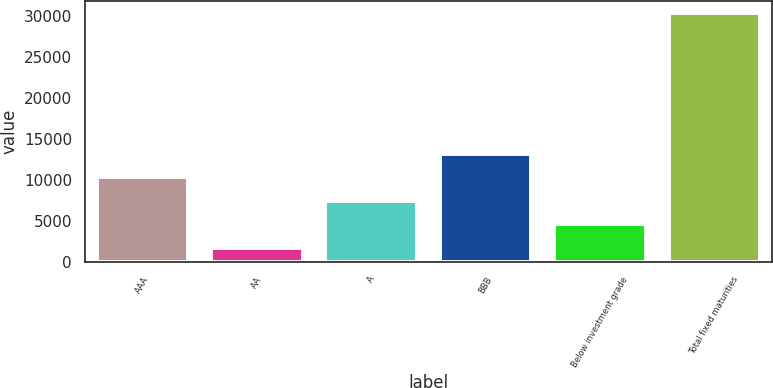Convert chart to OTSL. <chart><loc_0><loc_0><loc_500><loc_500><bar_chart><fcel>AAA<fcel>AA<fcel>A<fcel>BBB<fcel>Below investment grade<fcel>Total fixed maturities<nl><fcel>10282.5<fcel>1707<fcel>7424<fcel>13141<fcel>4565.5<fcel>30292<nl></chart> 